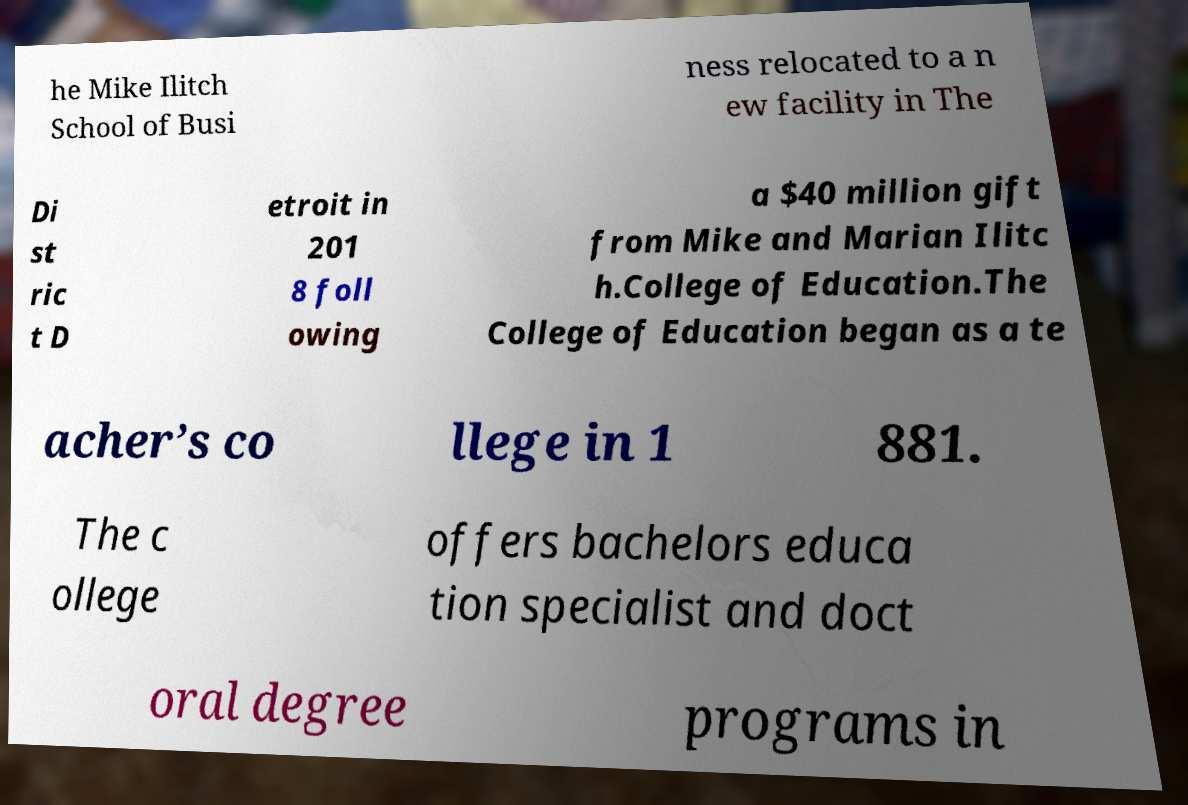There's text embedded in this image that I need extracted. Can you transcribe it verbatim? he Mike Ilitch School of Busi ness relocated to a n ew facility in The Di st ric t D etroit in 201 8 foll owing a $40 million gift from Mike and Marian Ilitc h.College of Education.The College of Education began as a te acher’s co llege in 1 881. The c ollege offers bachelors educa tion specialist and doct oral degree programs in 